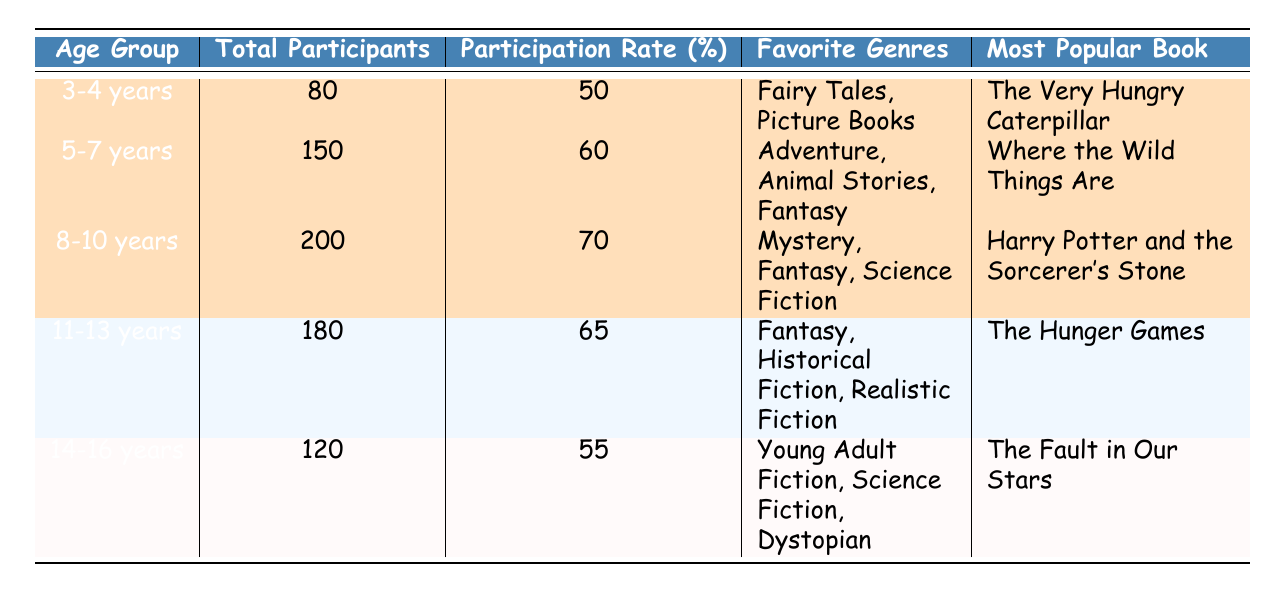What is the total number of participants in the 5-7 years age group? The table displays the total number of participants for each age group. For the 5-7 years age group, the total participants listed is 150.
Answer: 150 Which age group has the highest participation rate? According to the table, the participation rates for each age group are listed. The highest participation rate of 70% is for the 8-10 years age group.
Answer: 8-10 years How many total participants are there in the 3-4 years and 14-16 years age groups combined? For the 3-4 years age group, there are 80 participants, and for the 14-16 years age group, there are 120 participants. Summing these gives 80 + 120 = 200.
Answer: 200 What is the most popular book for the 8-10 years age group? The table indicates the most popular book for the 8-10 years age group is "Harry Potter and the Sorcerer's Stone."
Answer: Harry Potter and the Sorcerer's Stone Is the participation rate for the 14-16 years age group greater than 60%? The participation rate for the 14-16 years age group is 55%, which is less than 60%.
Answer: No What is the average participation rate of all the age groups? The participation rates for the age groups are 50%, 60%, 70%, 65%, and 55%. Adding them gives 50 + 60 + 70 + 65 + 55 = 300, then dividing by 5 gives an average of 300/5 = 60.
Answer: 60 Which age group enjoys Animal Stories as a favorite genre? The table shows favorite genres for each age group. The 5-7 years age group lists Animal Stories as one of its favorite genres.
Answer: 5-7 years How many more total participants are there in the 8-10 years age group than in the 14-16 years age group? The 8-10 years age group has 200 participants, and the 14-16 years age group has 120 participants. The difference is 200 - 120 = 80.
Answer: 80 Which age group and its corresponding favorite genres are highlighted in the table? The highlighted age groups along with their favorite genres are: 3-4 years (Fairy Tales, Picture Books), 5-7 years (Adventure, Animal Stories, Fantasy), and 8-10 years (Mystery, Fantasy, Science Fiction).
Answer: 3-4 years, 5-7 years, 8-10 years Is "The Hunger Games" the most popular book for the youngest age group? The most popular book for the youngest age group (3-4 years) is "The Very Hungry Caterpillar," while "The Hunger Games" is popular in the 11-13 years age group.
Answer: No 